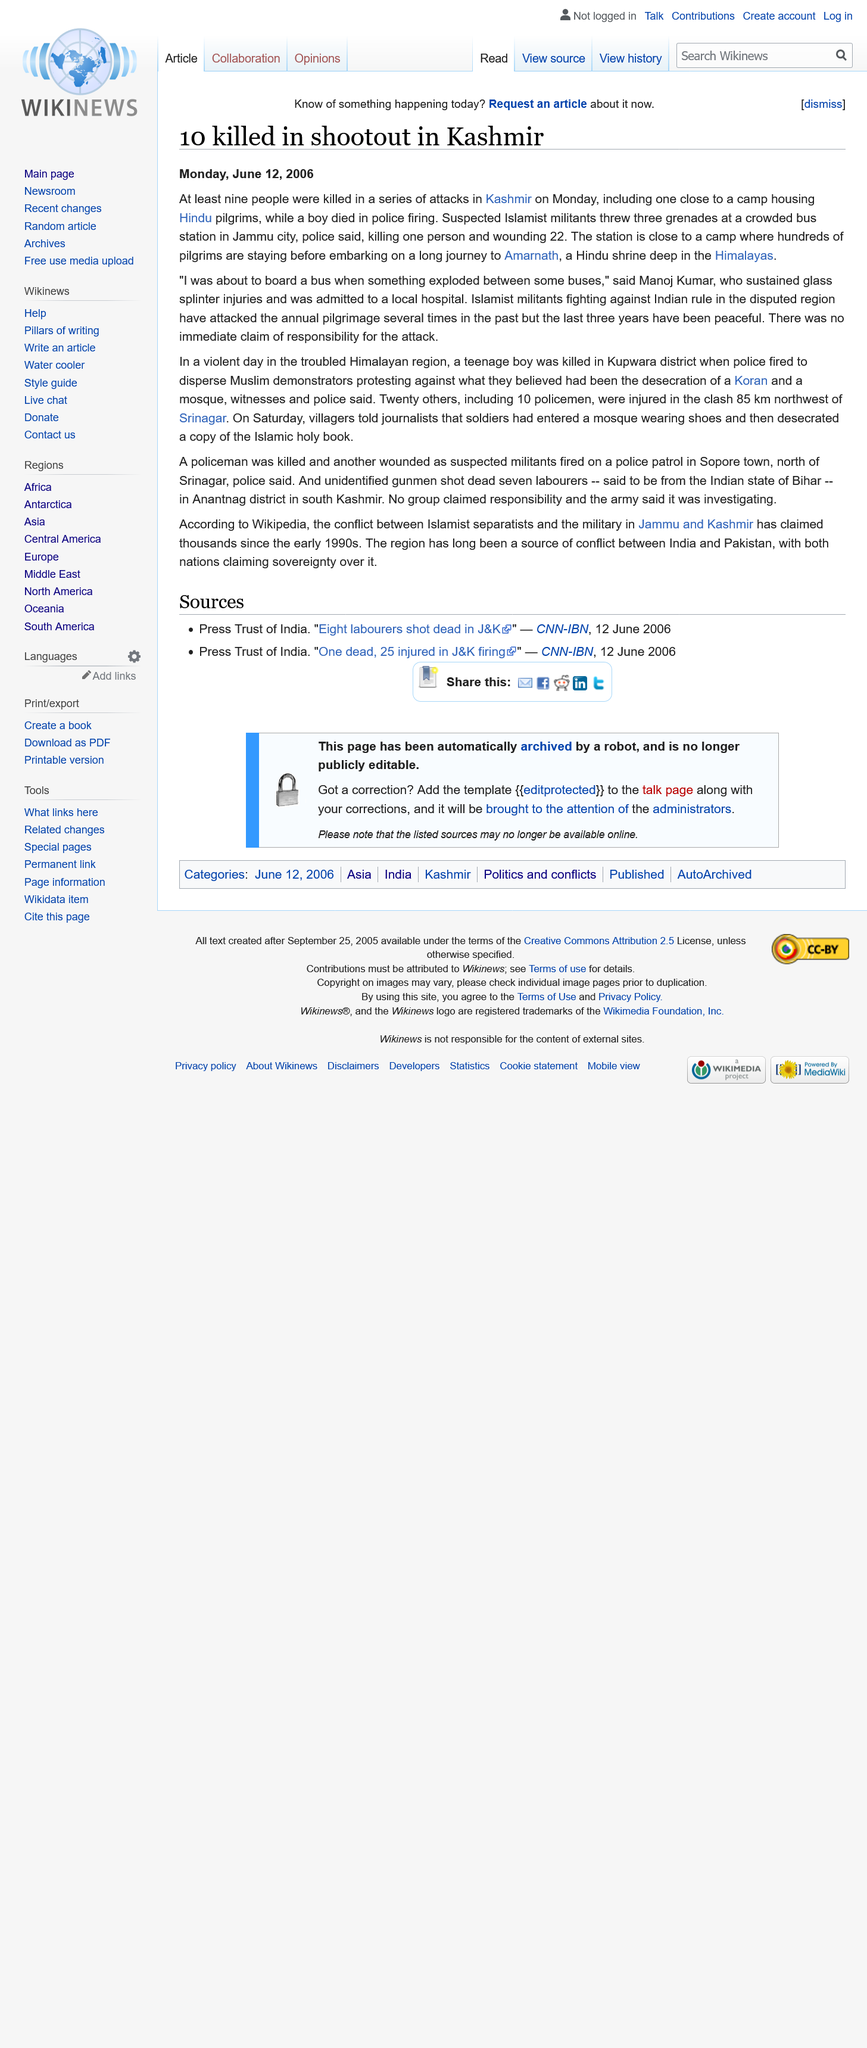Identify some key points in this picture. The text was written on Monday, June 12, 2006. Suspected Islamist militants threw three grenades at a crowded bus station. Ten people were killed in the shootout in Kashmir. 